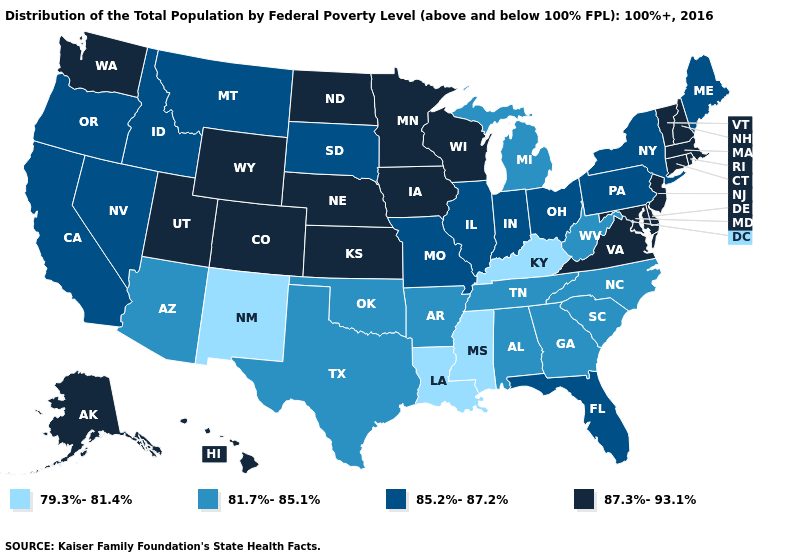Does Minnesota have the highest value in the USA?
Short answer required. Yes. Which states have the lowest value in the South?
Write a very short answer. Kentucky, Louisiana, Mississippi. What is the value of Michigan?
Be succinct. 81.7%-85.1%. What is the value of Utah?
Keep it brief. 87.3%-93.1%. Which states hav the highest value in the MidWest?
Write a very short answer. Iowa, Kansas, Minnesota, Nebraska, North Dakota, Wisconsin. Which states hav the highest value in the West?
Short answer required. Alaska, Colorado, Hawaii, Utah, Washington, Wyoming. Does the first symbol in the legend represent the smallest category?
Quick response, please. Yes. Name the states that have a value in the range 87.3%-93.1%?
Short answer required. Alaska, Colorado, Connecticut, Delaware, Hawaii, Iowa, Kansas, Maryland, Massachusetts, Minnesota, Nebraska, New Hampshire, New Jersey, North Dakota, Rhode Island, Utah, Vermont, Virginia, Washington, Wisconsin, Wyoming. What is the value of Delaware?
Keep it brief. 87.3%-93.1%. Among the states that border Wisconsin , does Michigan have the lowest value?
Answer briefly. Yes. Does the first symbol in the legend represent the smallest category?
Keep it brief. Yes. What is the value of Alaska?
Answer briefly. 87.3%-93.1%. Name the states that have a value in the range 79.3%-81.4%?
Be succinct. Kentucky, Louisiana, Mississippi, New Mexico. Name the states that have a value in the range 79.3%-81.4%?
Concise answer only. Kentucky, Louisiana, Mississippi, New Mexico. 